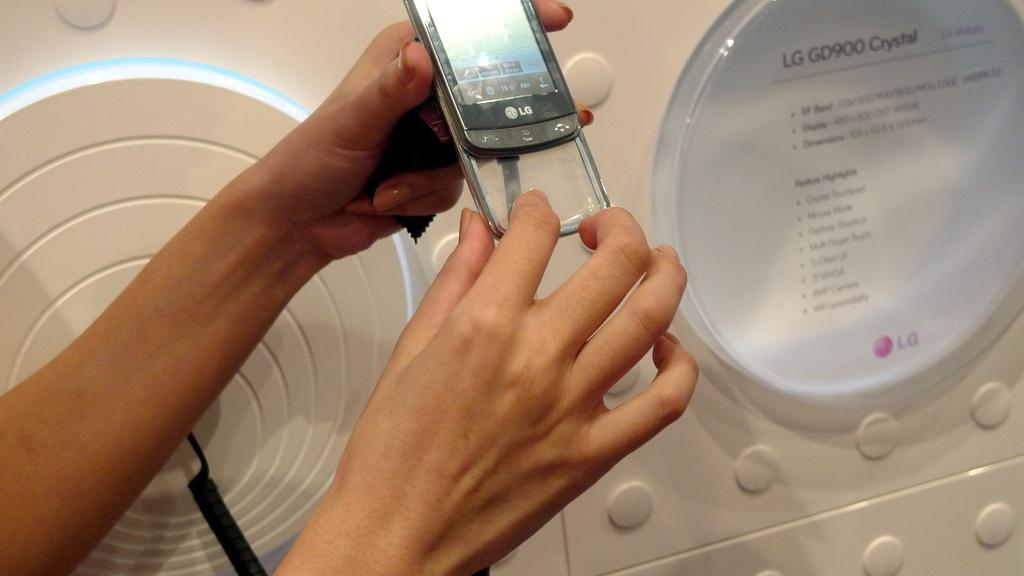<image>
Offer a succinct explanation of the picture presented. a phone that has an LG label on it 